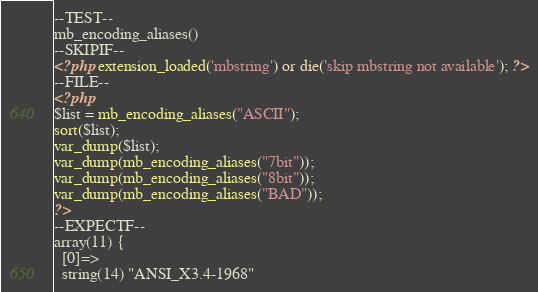Convert code to text. <code><loc_0><loc_0><loc_500><loc_500><_PHP_>--TEST--
mb_encoding_aliases()
--SKIPIF--
<?php extension_loaded('mbstring') or die('skip mbstring not available'); ?>
--FILE--
<?php
$list = mb_encoding_aliases("ASCII");
sort($list);
var_dump($list);
var_dump(mb_encoding_aliases("7bit"));
var_dump(mb_encoding_aliases("8bit"));
var_dump(mb_encoding_aliases("BAD"));
?>
--EXPECTF--
array(11) {
  [0]=>
  string(14) "ANSI_X3.4-1968"</code> 